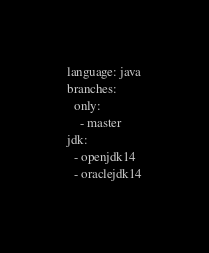Convert code to text. <code><loc_0><loc_0><loc_500><loc_500><_YAML_>language: java
branches:
  only:
    - master
jdk:
  - openjdk14
  - oraclejdk14
</code> 